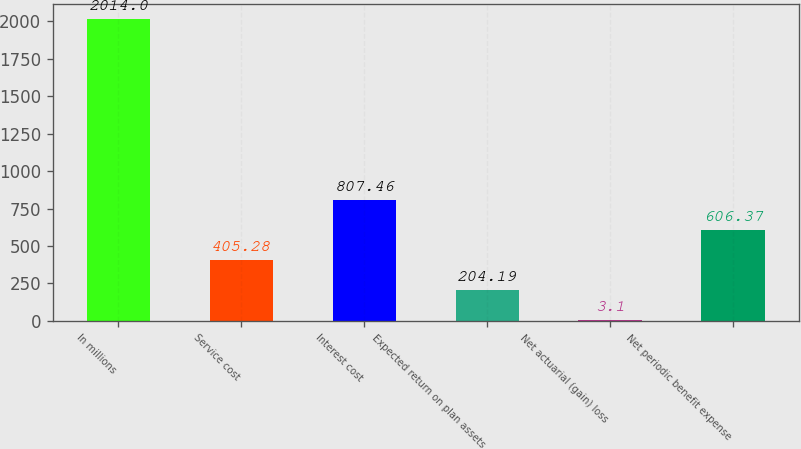Convert chart to OTSL. <chart><loc_0><loc_0><loc_500><loc_500><bar_chart><fcel>In millions<fcel>Service cost<fcel>Interest cost<fcel>Expected return on plan assets<fcel>Net actuarial (gain) loss<fcel>Net periodic benefit expense<nl><fcel>2014<fcel>405.28<fcel>807.46<fcel>204.19<fcel>3.1<fcel>606.37<nl></chart> 